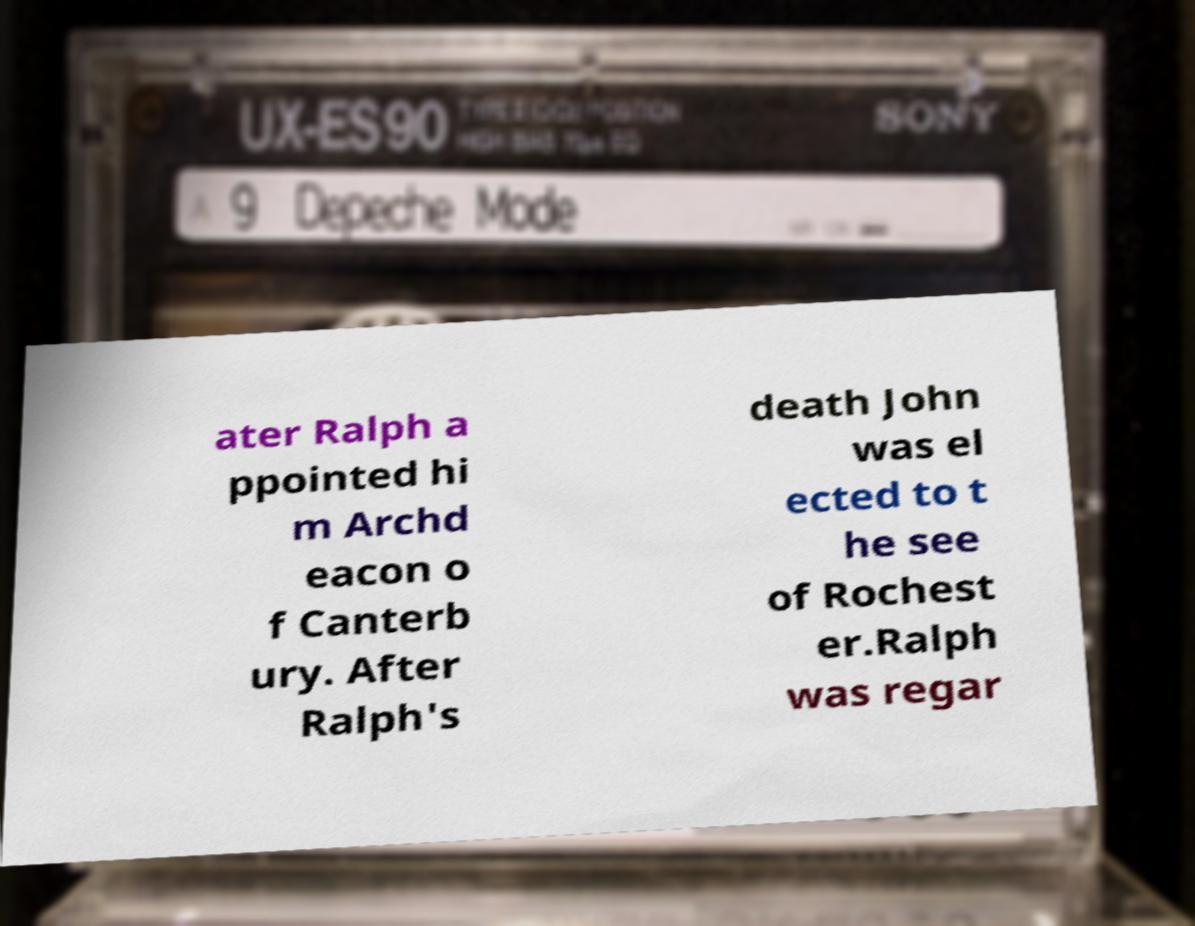I need the written content from this picture converted into text. Can you do that? ater Ralph a ppointed hi m Archd eacon o f Canterb ury. After Ralph's death John was el ected to t he see of Rochest er.Ralph was regar 